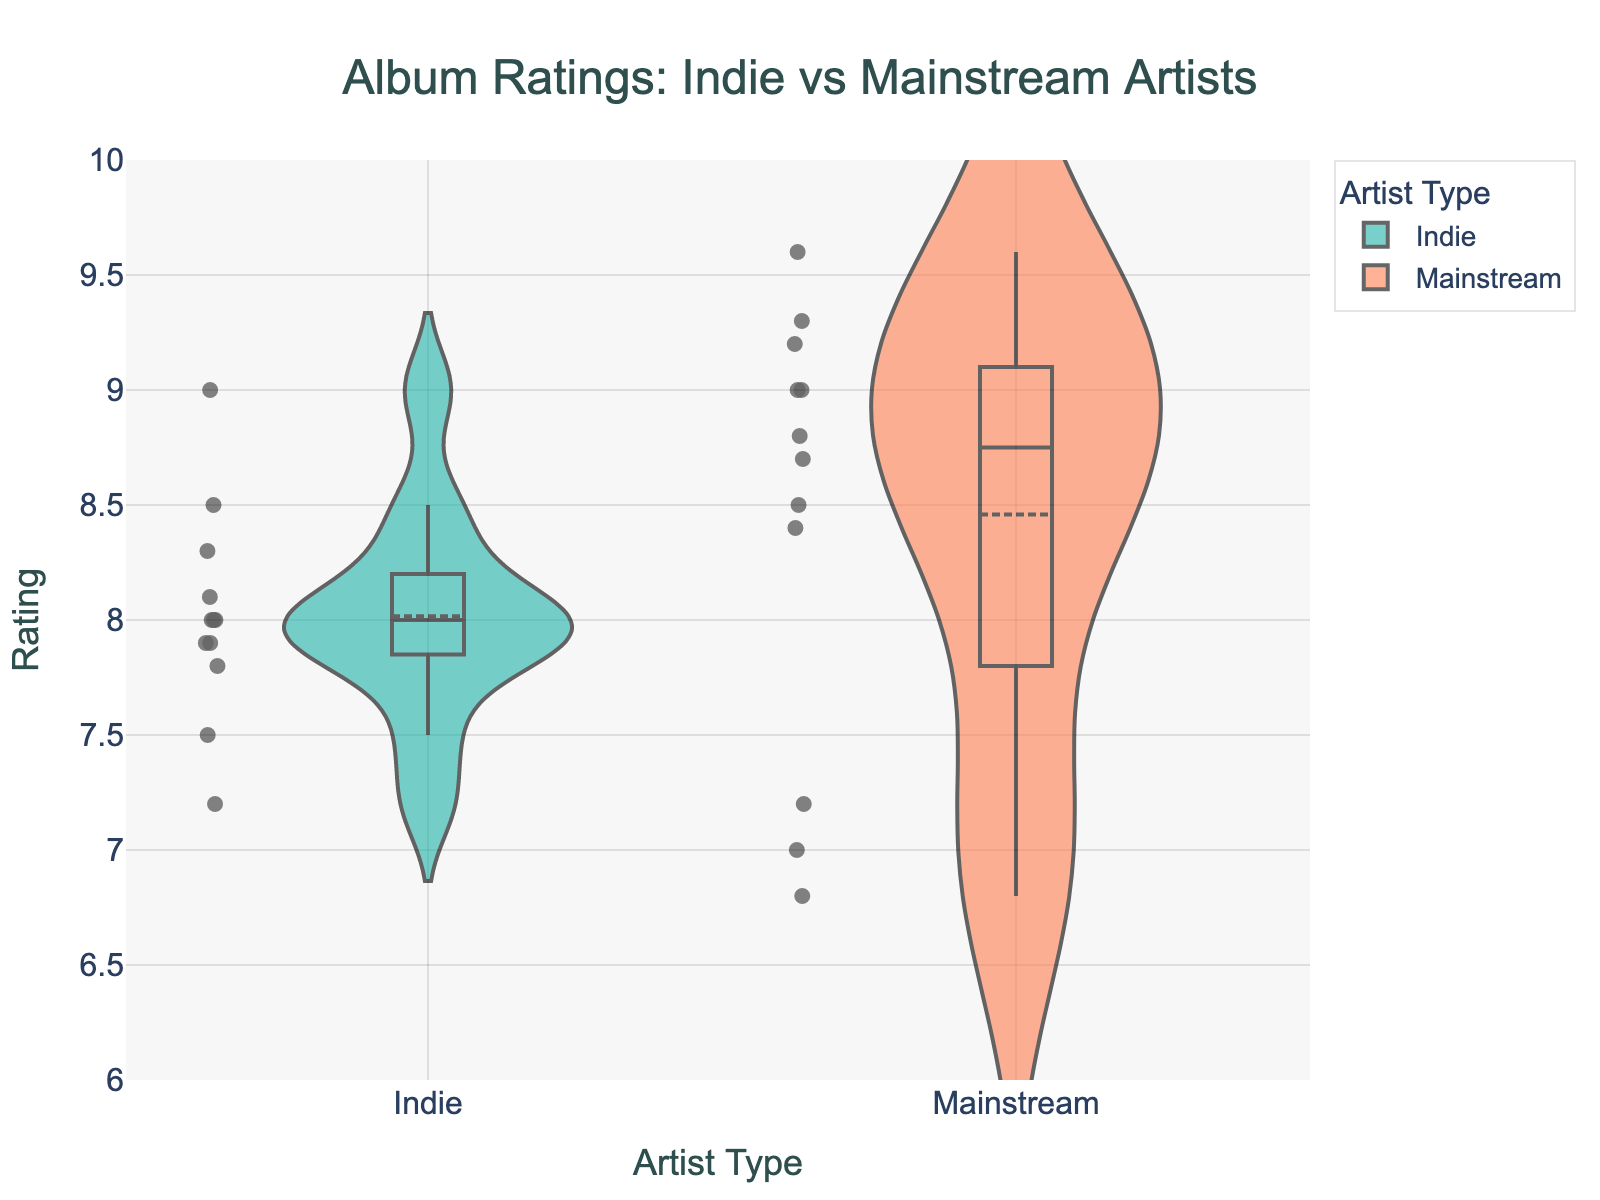How many artist types are represented in the plot? The x-axis of the violin plot shows artist types. There are two unique labels: "Indie" and "Mainstream".
Answer: 2 What is the range of album ratings on the y-axis? The y-axis of the violin plot represents album ratings, and its range is from 6 to 10.
Answer: 6 to 10 Which artist type has a higher mean rating? The violin plot shows a mean line for each artist type. The mainstream artist type has a higher mean rating because its mean line is positioned higher on the y-axis compared to the indie artist type.
Answer: Mainstream What is the median rating for Indie artists? The box plot overlay for Indie artists has a line inside the box indicating the median. The position of this line on the y-axis is approximately 8.0.
Answer: 8.0 Which artist type has a higher variability in ratings? The width of the violin plot gives a sense of variability. Indie artists show a wider distribution of ratings, indicating higher variability.
Answer: Indie What is the interquartile range (IQR) of album ratings for Mainstream artists? The interquartile range (IQR) is the range between the first quartile (Q1) and the third quartile (Q3) of the box plot. For Mainstream artists, Q1 is around 8.4 and Q3 is around 9.0. Therefore, IQR = Q3 - Q1 = 9.0 - 8.4 = 0.6.
Answer: 0.6 Which artist type has more outliers? Outliers are represented by individual points outside the main body of the violin plot and box plot. Both artist types show several individual points, but Indie appears to have slightly more outliers.
Answer: Indie What is the difference between the highest rating given to Indie and Mainstream artists? The highest rating for Indie artists is about 9.0, while for Mainstream artists, it is about 9.6. The difference is 9.6 - 9.0 = 0.6.
Answer: 0.6 Between Indie and Mainstream artists, which has the lowest album rating, and what is it? The lowest rating for Mainstream artists is around 6.8 (Drake), and the lowest for Indie artists is around 7.2 (Father John Misty), making Mainstream the lower of the two.
Answer: Mainstream, 6.8 